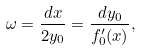Convert formula to latex. <formula><loc_0><loc_0><loc_500><loc_500>\omega = \frac { d x } { 2 y _ { 0 } } = \frac { d y _ { 0 } } { f _ { 0 } ^ { \prime } ( x ) } ,</formula> 